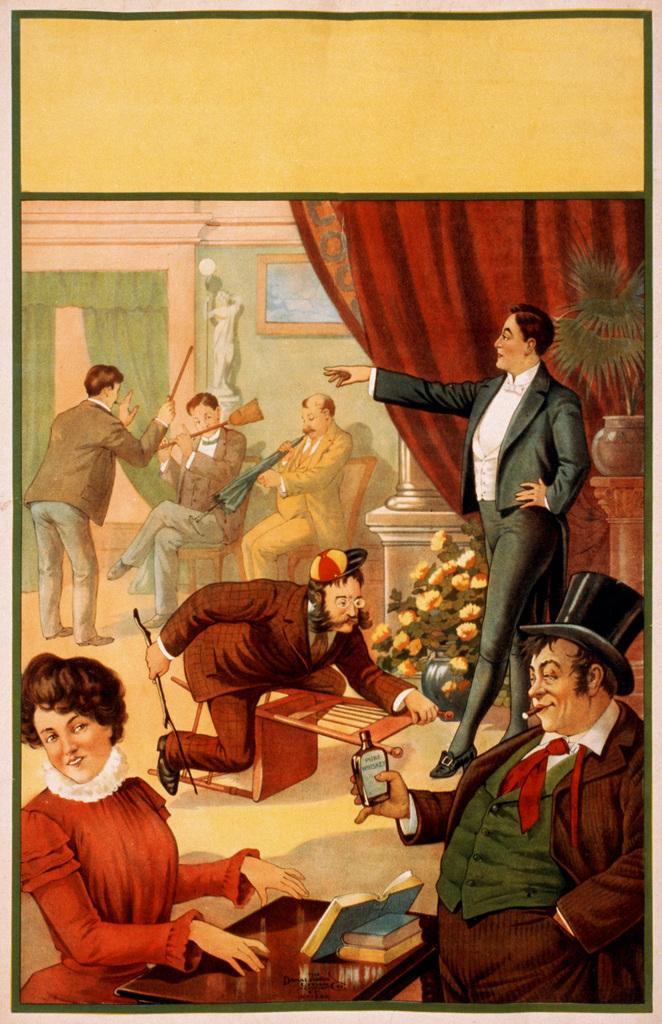Can you describe this image briefly? This image consists of a poster with a few images on it. At the bottom of the image there is a table with a few books on it. On the left side of the image a woman is sitting on the chair and a man is standing on the floor and holding a stick in his hands. In the background there is a wall with a picture frame and there is a sculpture. There are a few curtains. Two men are sitting on the chairs and holding musical instruments and a broom in their hands. On the right side of the image there is a plant in the pot. There is a pillar and there is a flower vase. A man is standing on the floor and another man is standing and he is holding a bottle in his hand. In the middle of the image there is an empty chair and there is a man. He is holding a stick in his hands. 